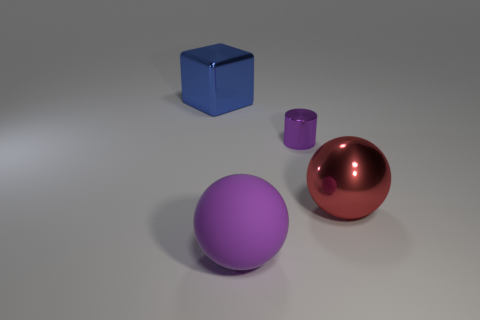How do the colors of the objects relate to each other? The objects' colors — red, blue, and purple — can be regarded as a visually harmonious selection, featuring primary and secondary colors. These color choices could be intentionally juxtaposed to create visual interest or to invoke specific moods or themes in the viewer. 